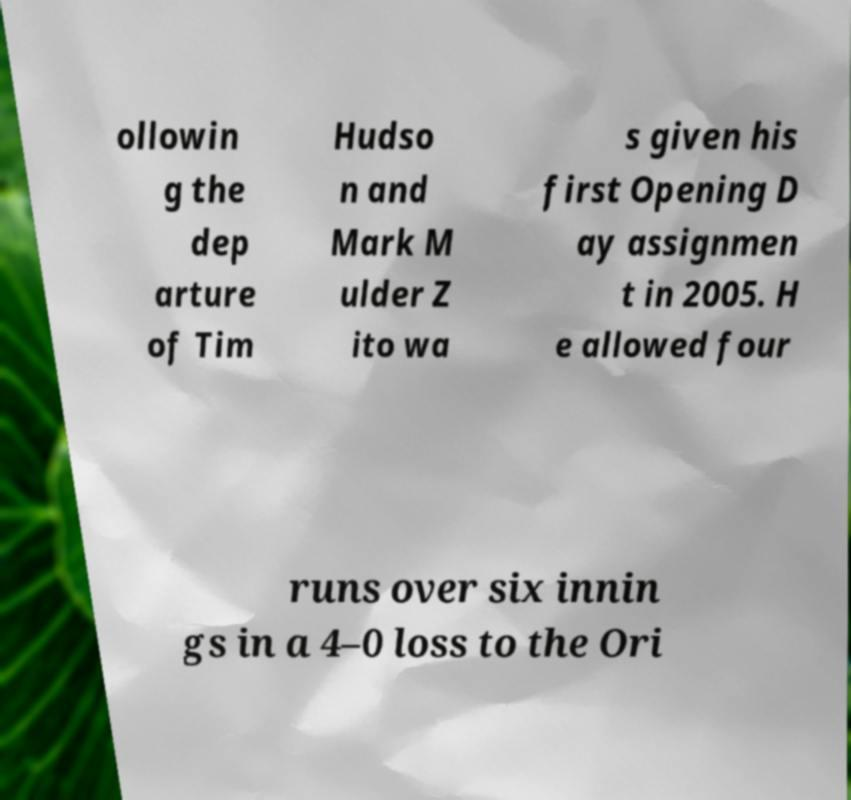There's text embedded in this image that I need extracted. Can you transcribe it verbatim? ollowin g the dep arture of Tim Hudso n and Mark M ulder Z ito wa s given his first Opening D ay assignmen t in 2005. H e allowed four runs over six innin gs in a 4–0 loss to the Ori 